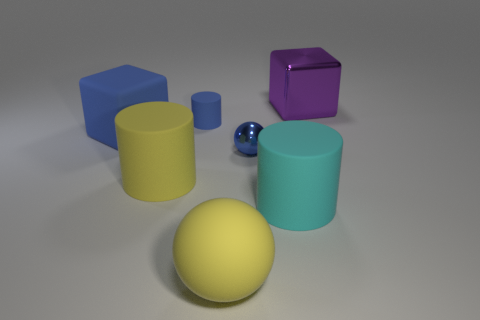Add 1 yellow matte objects. How many objects exist? 8 Subtract all yellow cylinders. How many cylinders are left? 2 Subtract all purple blocks. How many blocks are left? 1 Subtract 1 blocks. How many blocks are left? 1 Add 1 spheres. How many spheres are left? 3 Add 4 tiny blue metal things. How many tiny blue metal things exist? 5 Subtract 0 red balls. How many objects are left? 7 Subtract all spheres. How many objects are left? 5 Subtract all red cylinders. Subtract all brown spheres. How many cylinders are left? 3 Subtract all purple cubes. How many brown balls are left? 0 